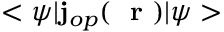<formula> <loc_0><loc_0><loc_500><loc_500>< \psi | { j } _ { o p } ( r ) | \psi ></formula> 